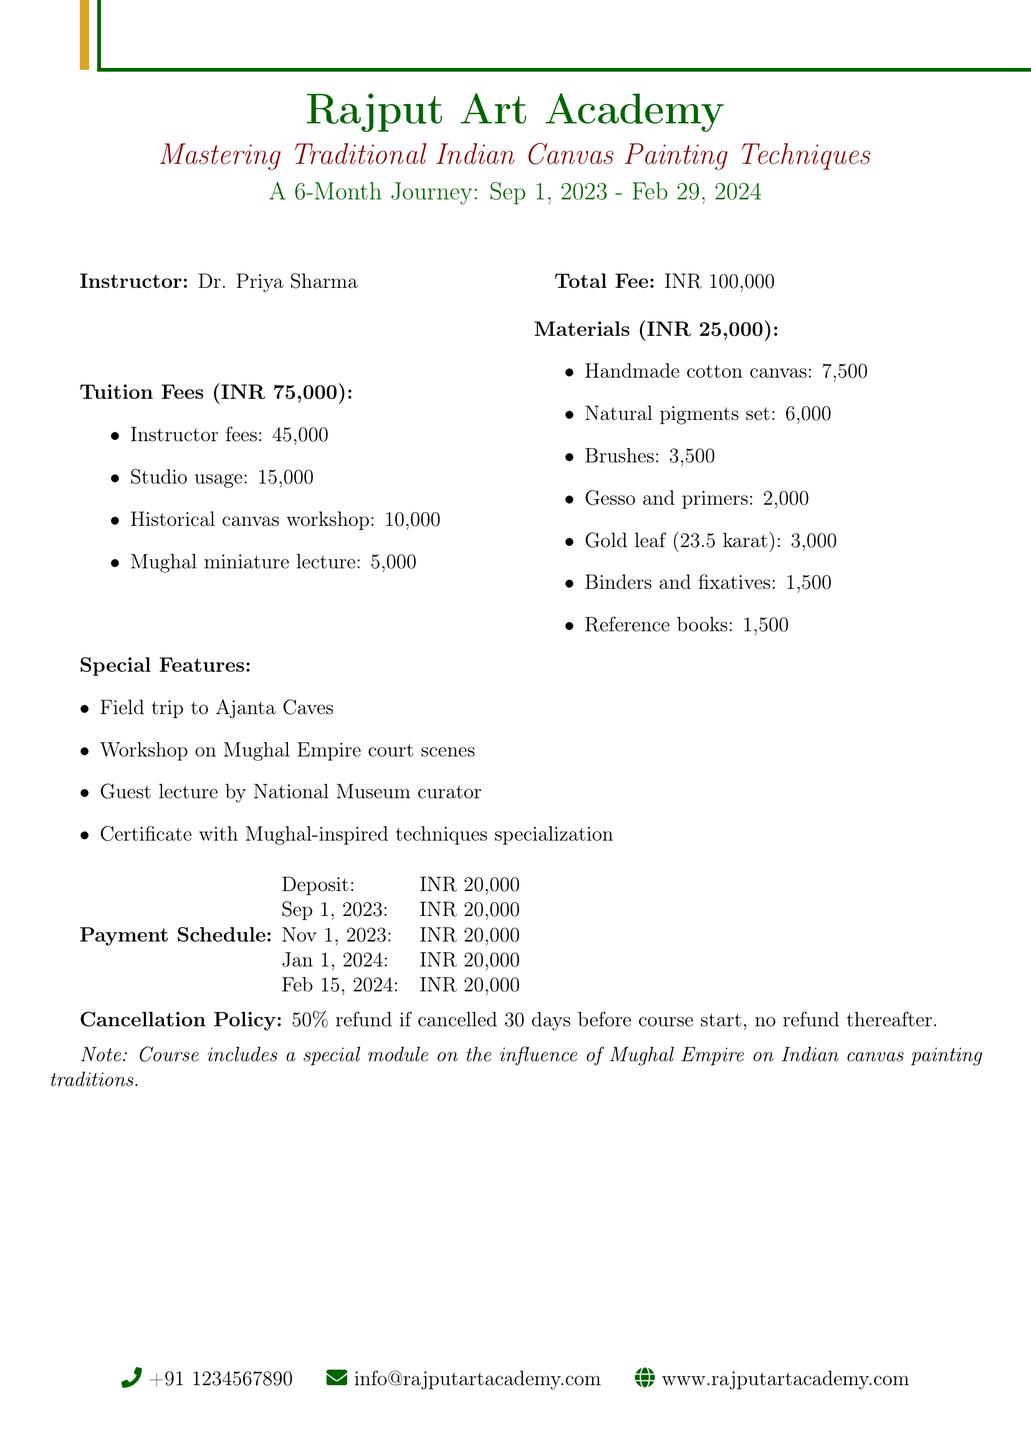What is the course title? The course title is found at the beginning of the document, describing the focus of the course.
Answer: Mastering Traditional Indian Canvas Painting Techniques: A 6-Month Journey Who is the instructor? The instructor's name is provided in the document to highlight who will be teaching the course.
Answer: Dr. Priya Sharma What is the total tuition fee? The total tuition fee is explicitly stated in the document under the tuition fees section.
Answer: INR 75000 When does the course start? The start date for the course is mentioned in the introductory section of the document.
Answer: 2023-09-01 What is the amount for the deposit? The deposit amount is stated in the payment terms section of the document.
Answer: INR 20000 How many historical reference books are included in the materials? The document lists the materials breakdown, which includes historical reference books among other items.
Answer: 1,500 What is the payment due on November 1, 2023? The payment schedule provides information on due dates and amounts throughout the course duration.
Answer: INR 20000 Is there a field trip included in the course? Special features are listed in the document, mentioning if a field trip is part of the course.
Answer: Yes, to Ajanta Caves What is the cancellation policy? The cancellation policy outlines the conditions for refunds and is specified in the document.
Answer: 50% refund if cancelled 30 days before course start, no refund thereafter 